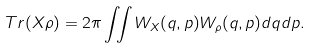<formula> <loc_0><loc_0><loc_500><loc_500>T r ( X \rho ) = 2 \pi \iint W _ { X } ( q , p ) W _ { \rho } ( q , p ) d q d p .</formula> 